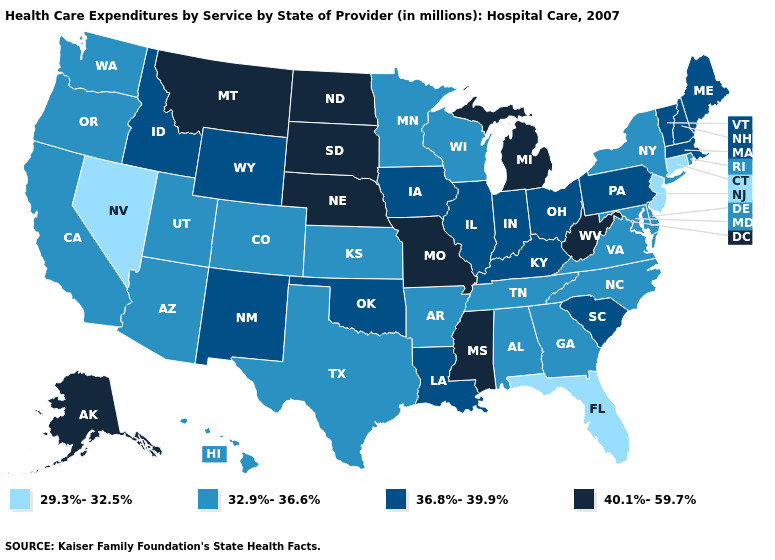What is the value of Oregon?
Keep it brief. 32.9%-36.6%. Does Wyoming have a higher value than Delaware?
Keep it brief. Yes. What is the value of New Hampshire?
Give a very brief answer. 36.8%-39.9%. How many symbols are there in the legend?
Short answer required. 4. Among the states that border Mississippi , which have the lowest value?
Short answer required. Alabama, Arkansas, Tennessee. Which states have the lowest value in the USA?
Quick response, please. Connecticut, Florida, Nevada, New Jersey. Does the first symbol in the legend represent the smallest category?
Keep it brief. Yes. Name the states that have a value in the range 40.1%-59.7%?
Write a very short answer. Alaska, Michigan, Mississippi, Missouri, Montana, Nebraska, North Dakota, South Dakota, West Virginia. Name the states that have a value in the range 32.9%-36.6%?
Give a very brief answer. Alabama, Arizona, Arkansas, California, Colorado, Delaware, Georgia, Hawaii, Kansas, Maryland, Minnesota, New York, North Carolina, Oregon, Rhode Island, Tennessee, Texas, Utah, Virginia, Washington, Wisconsin. What is the value of Oregon?
Quick response, please. 32.9%-36.6%. Does Massachusetts have a higher value than Nevada?
Keep it brief. Yes. What is the value of Connecticut?
Be succinct. 29.3%-32.5%. What is the highest value in the USA?
Concise answer only. 40.1%-59.7%. Among the states that border Alabama , does Florida have the lowest value?
Answer briefly. Yes. What is the value of Maryland?
Short answer required. 32.9%-36.6%. 